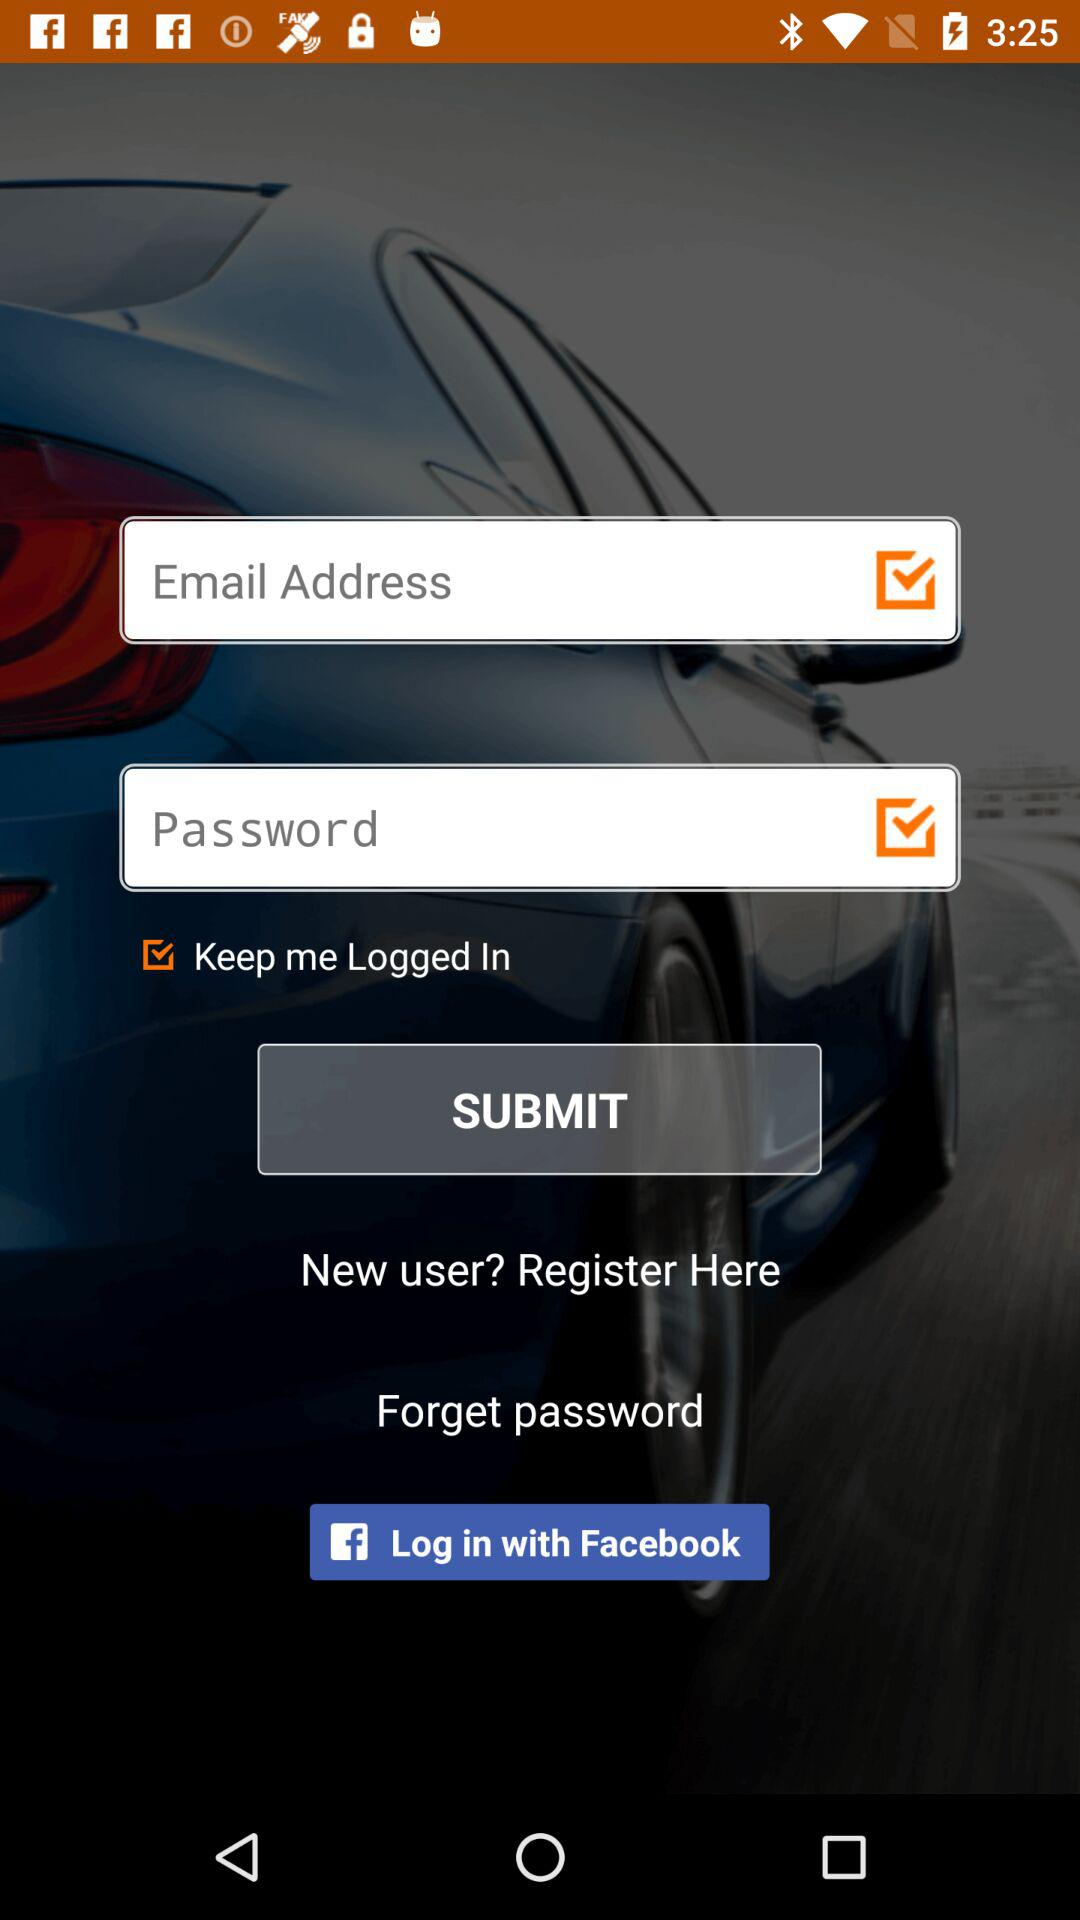What is the status of the "Keep me Logged In"? The status is on. 